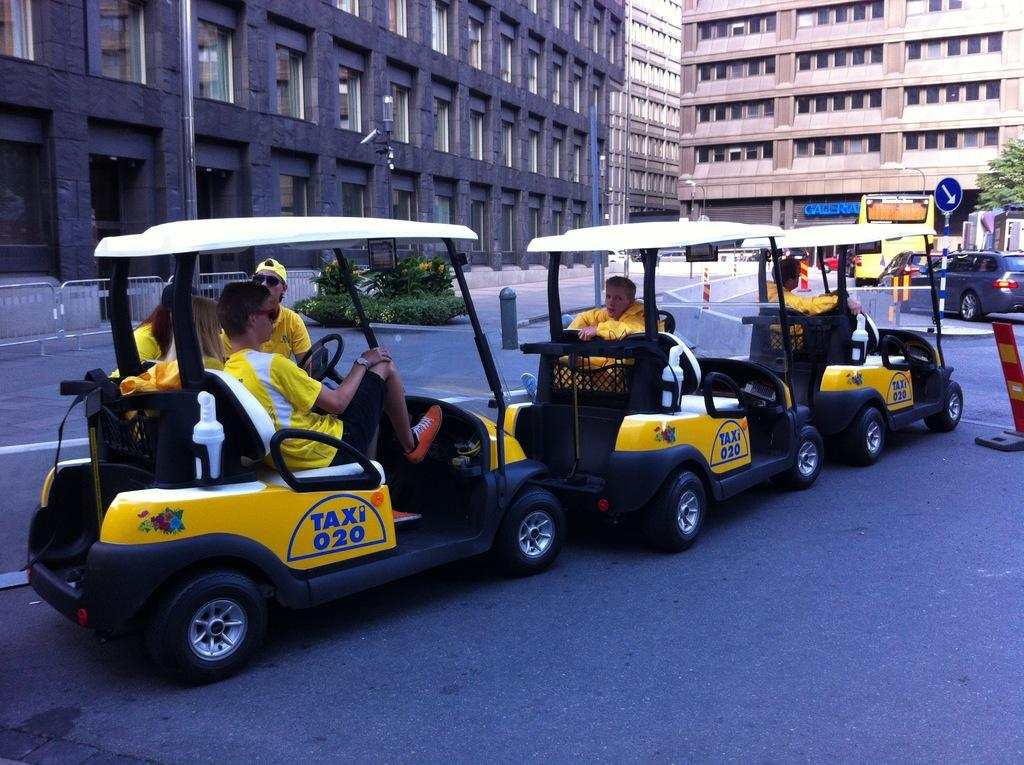What can be seen on the road in the image? There are cars parked on the road in the image. What are the people in the cars doing? People are sitting in the cars. What can be seen in the distance in the image? There are buildings visible in the background of the image. What type of vegetation is present in the image? There is a tree present in the image. Can you see any friends or donkeys interacting with the cars in the image? There are no friends or donkeys present in the image; it only shows parked cars with people sitting inside. What type of rake is being used to clean the tree in the image? There is no rake present in the image, and the tree is not being cleaned or maintained. 